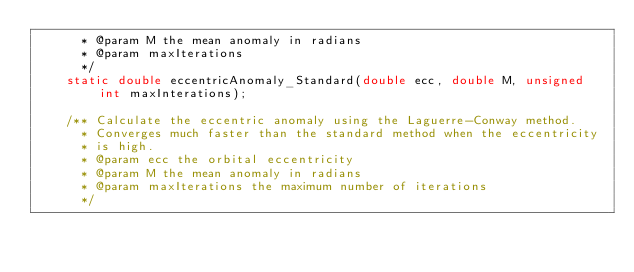Convert code to text. <code><loc_0><loc_0><loc_500><loc_500><_C_>      * @param M the mean anomaly in radians
      * @param maxIterations
      */
    static double eccentricAnomaly_Standard(double ecc, double M, unsigned int maxInterations);

    /** Calculate the eccentric anomaly using the Laguerre-Conway method.
      * Converges much faster than the standard method when the eccentricity
      * is high.
      * @param ecc the orbital eccentricity
      * @param M the mean anomaly in radians
      * @param maxIterations the maximum number of iterations
      */</code> 